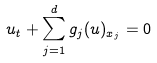<formula> <loc_0><loc_0><loc_500><loc_500>u _ { t } + \sum _ { j = 1 } ^ { d } g _ { j } ( u ) _ { x _ { j } } = 0</formula> 